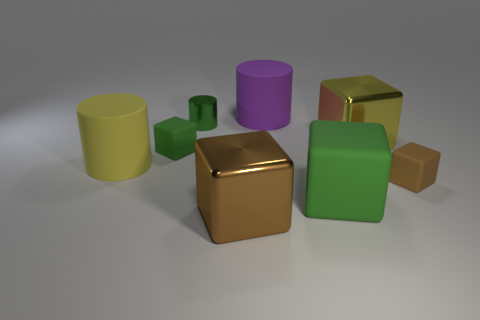Is there a big purple cylinder that has the same material as the purple thing? There is indeed a large purple cylinder present, but it does not share its material with any other purple object, as there are no other purple items to compare it with. 